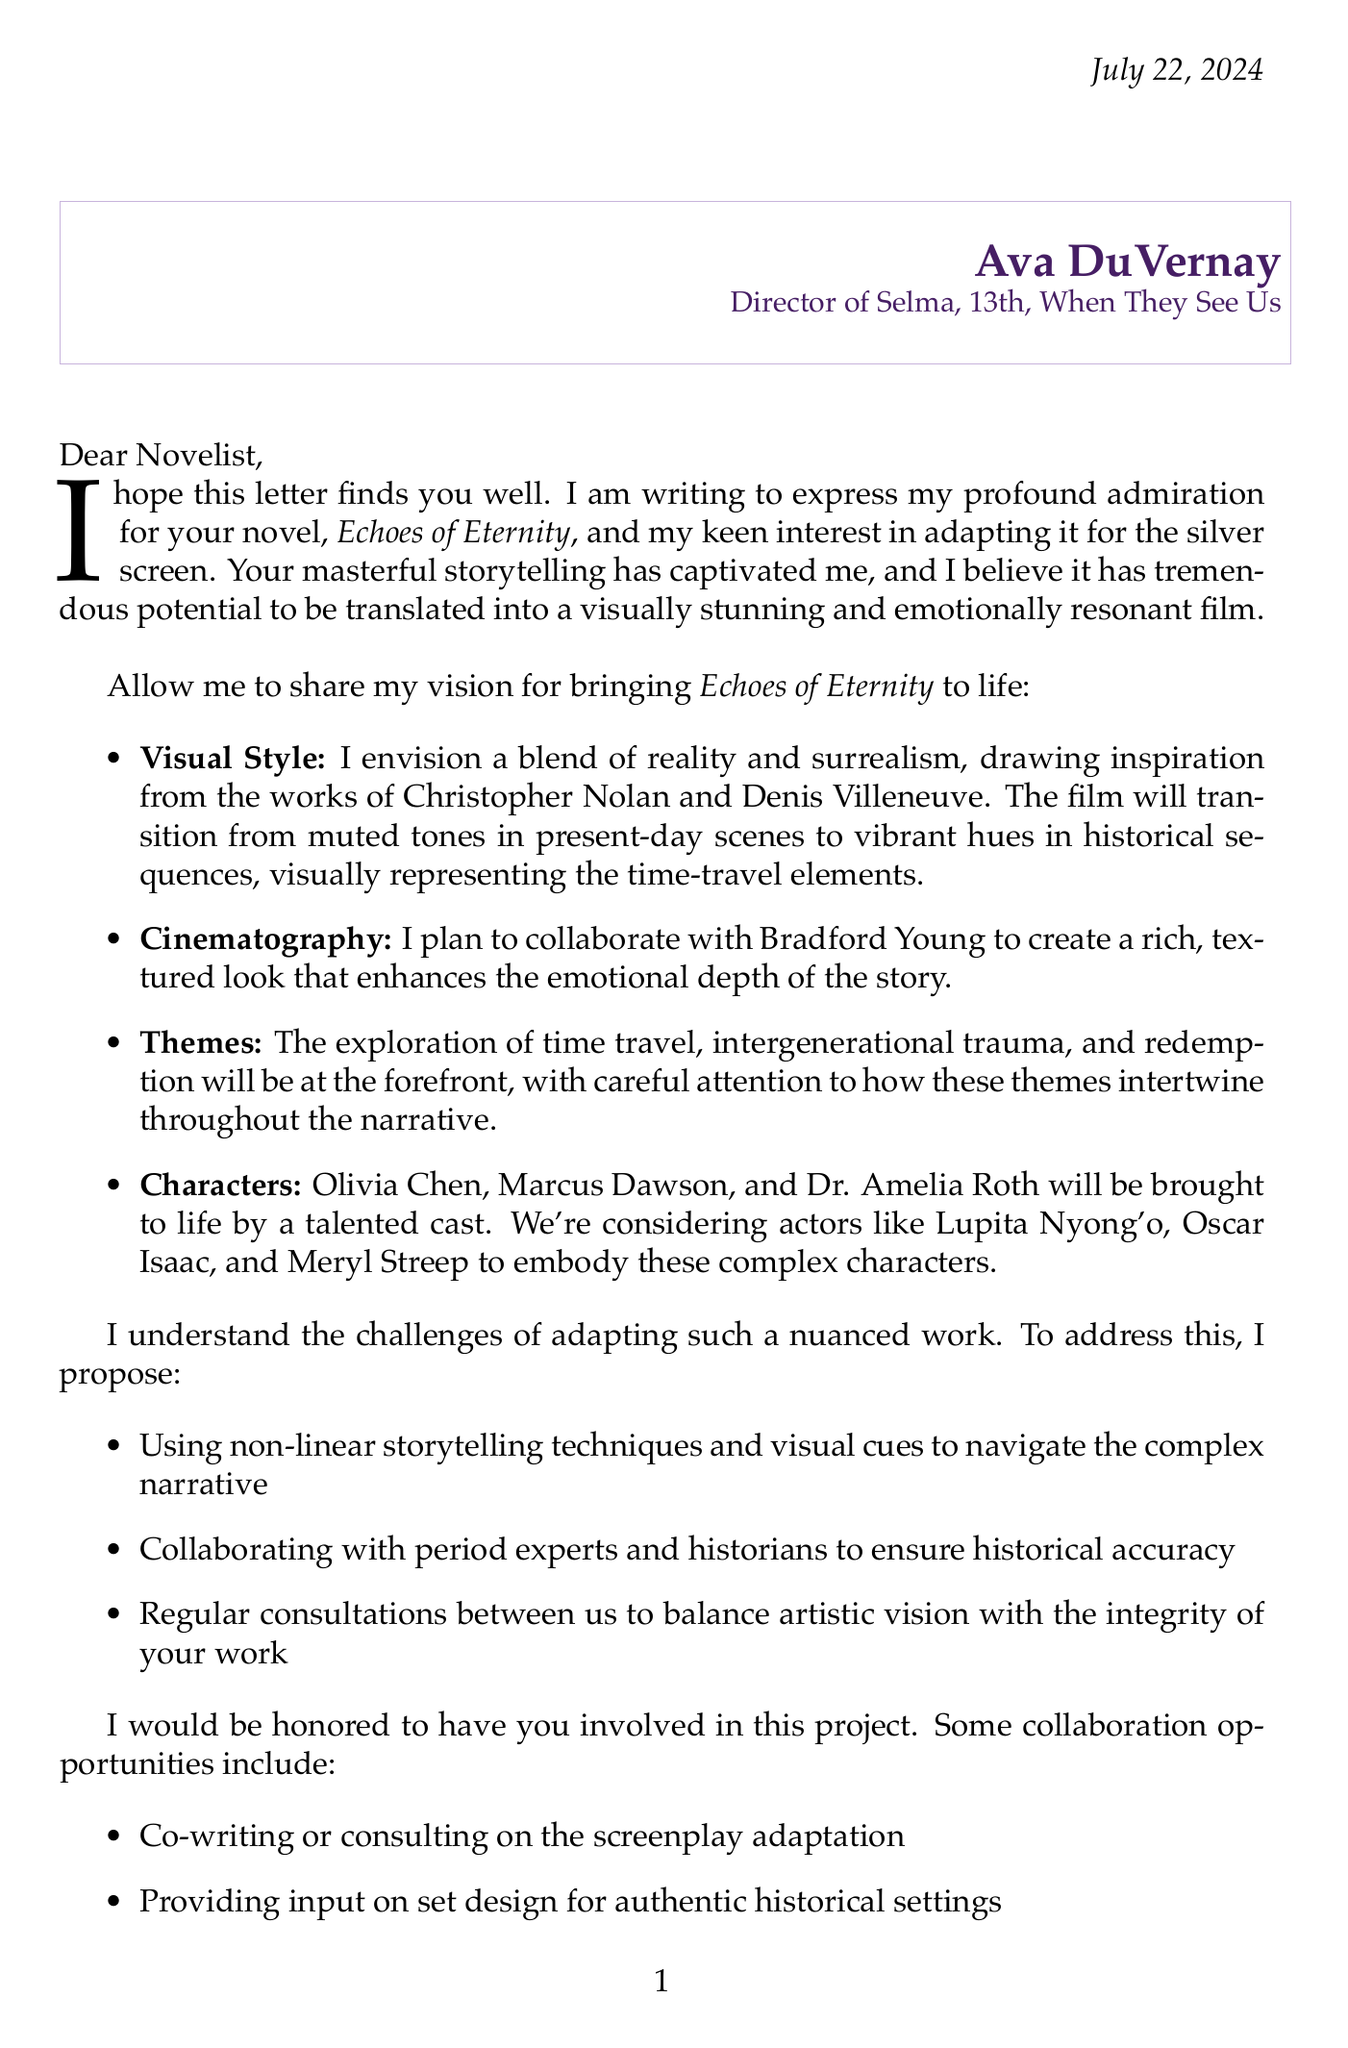What is the name of the director? The letter identifies Ava DuVernay as the director interested in the adaptation.
Answer: Ava DuVernay What is the title of the novel being adapted? The letter mentions the title of the novel as Echoes of Eternity.
Answer: Echoes of Eternity What studio is proposed for the film's production? The letter states that A24 is the studio intended for the film.
Answer: A24 What is the proposed budget for the film adaptation? The letter mentions a proposed budget of $40 million for the adaptation.
Answer: $40 million Who are the potential actors mentioned for key characters? The letter lists Lupita Nyong'o, Oscar Isaac, and Meryl Streep as possible actors for the film.
Answer: Lupita Nyong'o, Oscar Isaac, Meryl Streep What key theme is central to the narrative? The letter highlights time travel as a significant theme in the adaptation.
Answer: Time travel What is the targeted release timeframe for the film? The letter mentions a target release date in Fall 2025.
Answer: Fall 2025 How does the director plan to ensure historical accuracy? The letter states that collaboration with period experts and historians will be used to ensure historical accuracy.
Answer: Collaborating with period experts and historians What type of collaboration is being proposed for the screenplay? The letter invites the novelist to co-write or consult on the screenplay adaptation.
Answer: Co-write or consult on the screenplay 